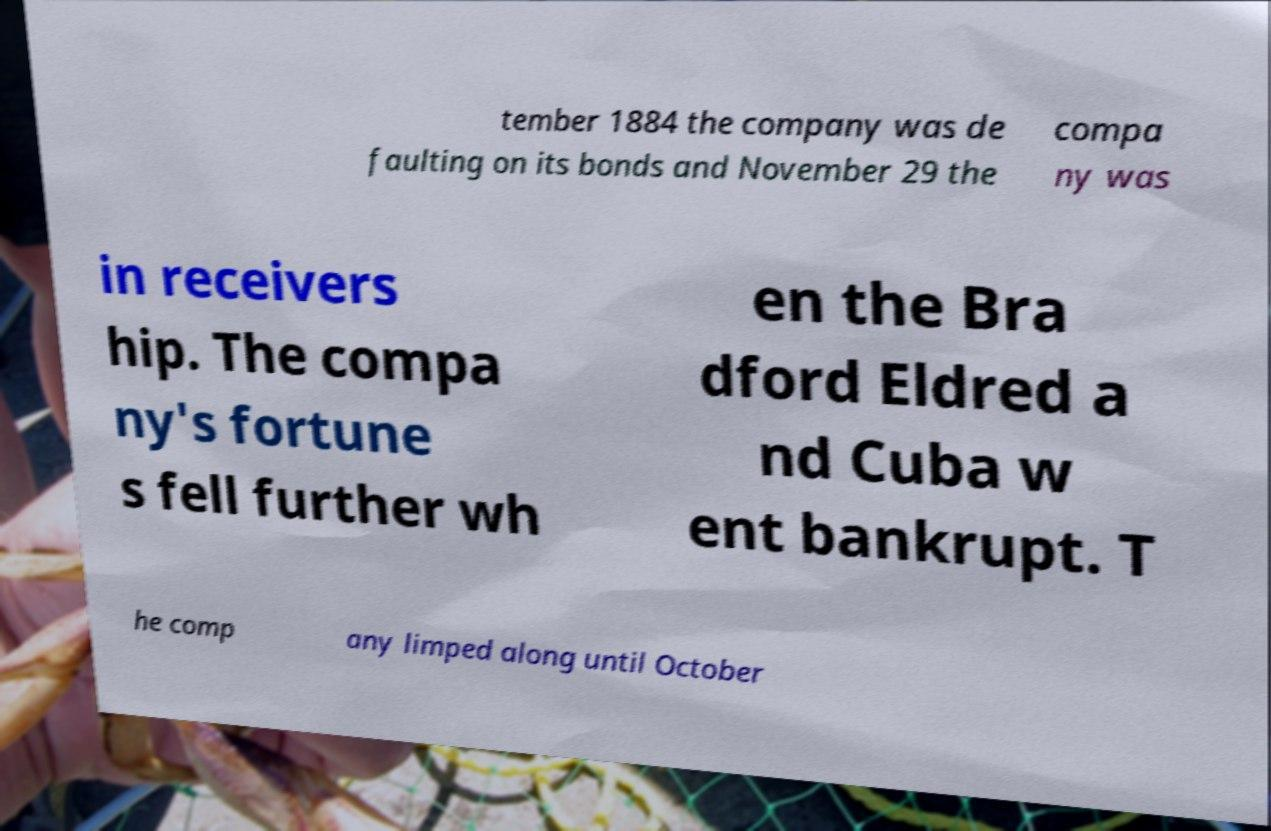Can you read and provide the text displayed in the image?This photo seems to have some interesting text. Can you extract and type it out for me? tember 1884 the company was de faulting on its bonds and November 29 the compa ny was in receivers hip. The compa ny's fortune s fell further wh en the Bra dford Eldred a nd Cuba w ent bankrupt. T he comp any limped along until October 